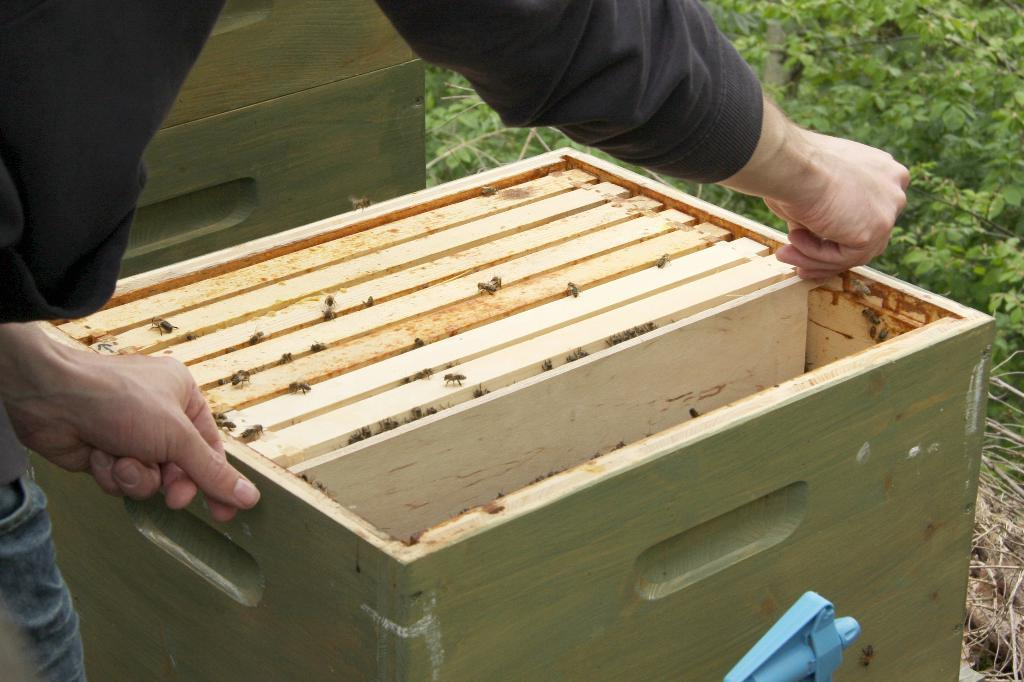Who is present in the image? There is a person in the image. What is the person holding in the image? The person is holding a wooden box. What is inside the wooden box? The wooden box contains honey bees. What can be seen in the background of the image? There are plants in the background of the image. What type of key is used to open the channel in the image? There is no key or channel present in the image. The image features a person holding a wooden box containing honey bees, with plants in the background. 